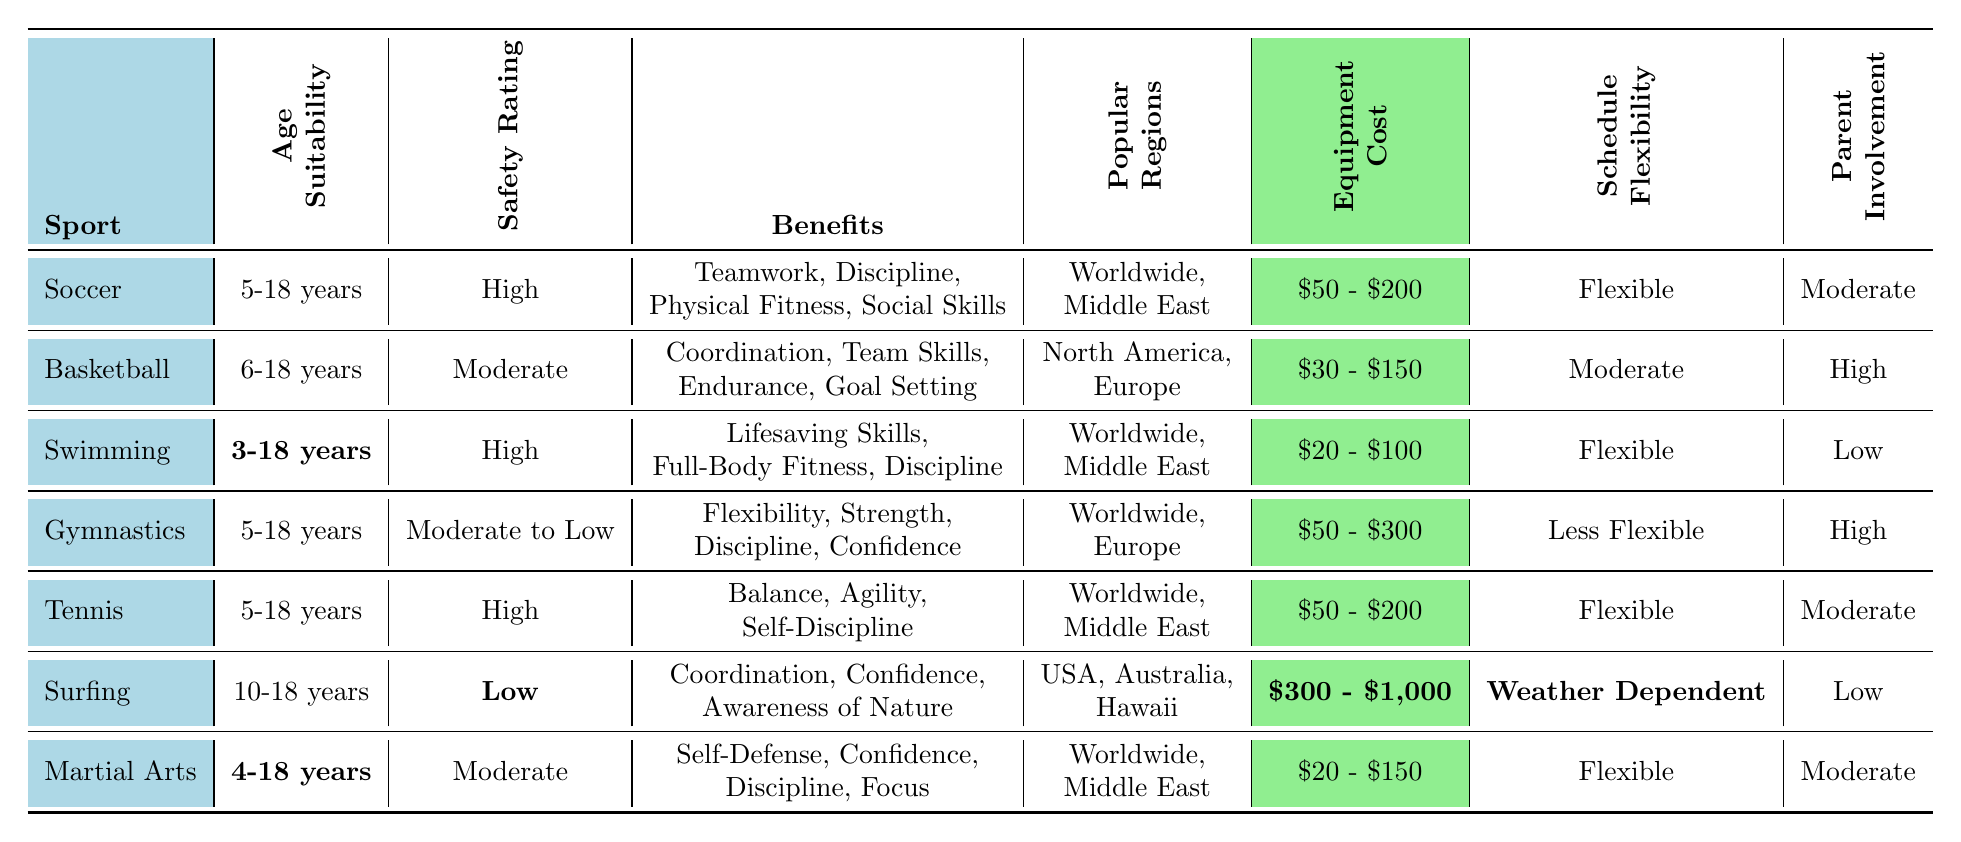What is the safety rating of Swimming? Swimming has a safety rating listed in the table as High.
Answer: High Which sports have a moderate level of parent involvement? The table shows that Soccer, Tennis, and Martial Arts all have Moderate levels of parent involvement.
Answer: Soccer, Tennis, and Martial Arts What is the age suitability range for Gymnastics? The table states that Gymnastics is suitable for children aged 5-18 years.
Answer: 5-18 years Is Surfing considered a high safety rating sport? The table indicates that Surfing has a Low safety rating, so it is not considered high.
Answer: No Which sport requires the most expensive equipment? From the table, Surfing has the highest equipment cost range, listed as $300 - $1,000.
Answer: Surfing How many sports have a flexible schedule? The table lists Soccer, Swimming, Tennis, and Martial Arts as having a Flexible schedule, totaling four sports.
Answer: 4 What benefits are associated with Martial Arts? According to the table, the benefits of Martial Arts include Self-Defense, Confidence, Discipline, and Focus.
Answer: Self-Defense, Confidence, Discipline, Focus What is the average equipment cost of Soccer and Basketball? The equipment cost for Soccer is between $50 - $200, and for Basketball, it’s $30 - $150. Taking the averages of both ranges: Soccer average = (50 + 200)/2 = $125, Basketball average = (30 + 150)/2 = $90.5. Thus, the total average cost is (125 + 90.5)/2 = $107.75.
Answer: $107.75 Which sport has the least age suitability? Surfing is only suitable for children aged 10-18 years, which is the least age suitability among the listed sports.
Answer: Surfing What are the popular regions for Swimming? The popular regions for Swimming, as per the table, are Worldwide and the Middle East.
Answer: Worldwide, Middle East Which sport has the highest parent involvement? The table indicates that Basketball and Gymnastics have high levels of parent involvement.
Answer: Basketball and Gymnastics 